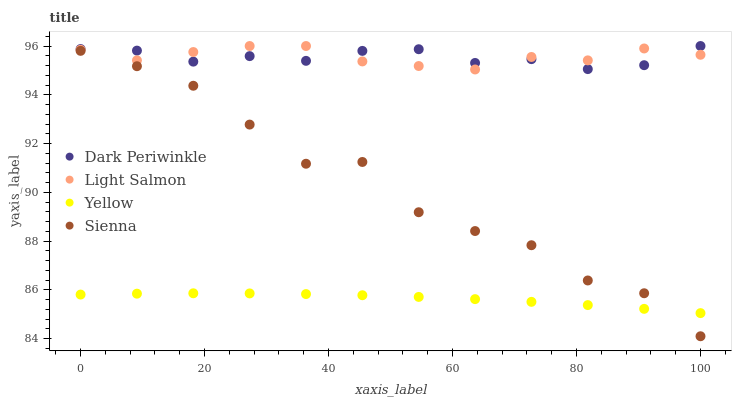Does Yellow have the minimum area under the curve?
Answer yes or no. Yes. Does Light Salmon have the maximum area under the curve?
Answer yes or no. Yes. Does Dark Periwinkle have the minimum area under the curve?
Answer yes or no. No. Does Dark Periwinkle have the maximum area under the curve?
Answer yes or no. No. Is Yellow the smoothest?
Answer yes or no. Yes. Is Sienna the roughest?
Answer yes or no. Yes. Is Light Salmon the smoothest?
Answer yes or no. No. Is Light Salmon the roughest?
Answer yes or no. No. Does Sienna have the lowest value?
Answer yes or no. Yes. Does Light Salmon have the lowest value?
Answer yes or no. No. Does Dark Periwinkle have the highest value?
Answer yes or no. Yes. Does Yellow have the highest value?
Answer yes or no. No. Is Sienna less than Light Salmon?
Answer yes or no. Yes. Is Light Salmon greater than Yellow?
Answer yes or no. Yes. Does Dark Periwinkle intersect Light Salmon?
Answer yes or no. Yes. Is Dark Periwinkle less than Light Salmon?
Answer yes or no. No. Is Dark Periwinkle greater than Light Salmon?
Answer yes or no. No. Does Sienna intersect Light Salmon?
Answer yes or no. No. 